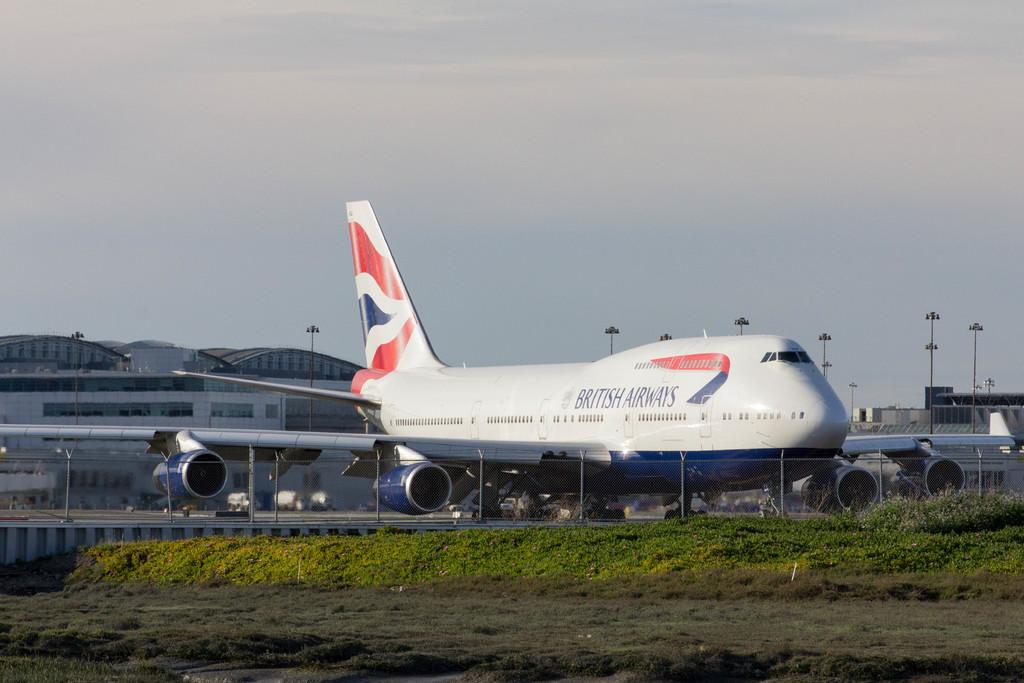<image>
Render a clear and concise summary of the photo. The airplane has British airlines on it and is on the ground. 